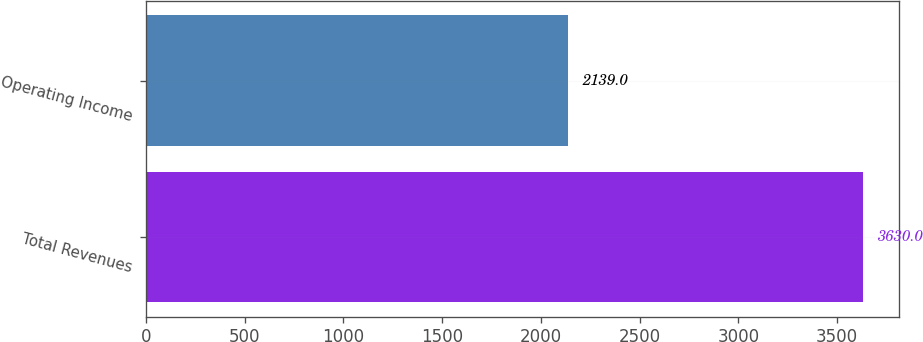Convert chart to OTSL. <chart><loc_0><loc_0><loc_500><loc_500><bar_chart><fcel>Total Revenues<fcel>Operating Income<nl><fcel>3630<fcel>2139<nl></chart> 